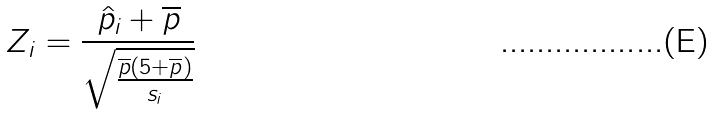<formula> <loc_0><loc_0><loc_500><loc_500>Z _ { i } = \frac { \hat { p } _ { i } + \overline { p } } { \sqrt { \frac { \overline { p } ( 5 + \overline { p } ) } { s _ { i } } } }</formula> 